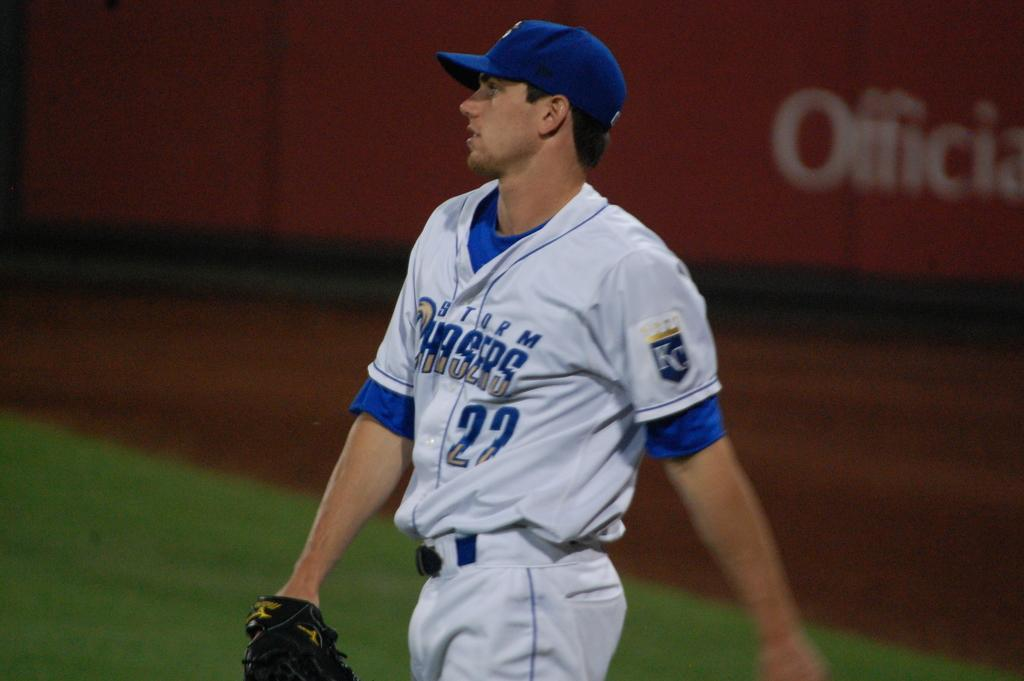Provide a one-sentence caption for the provided image. A baseball player with the words Storm Chasers on his jersey. 